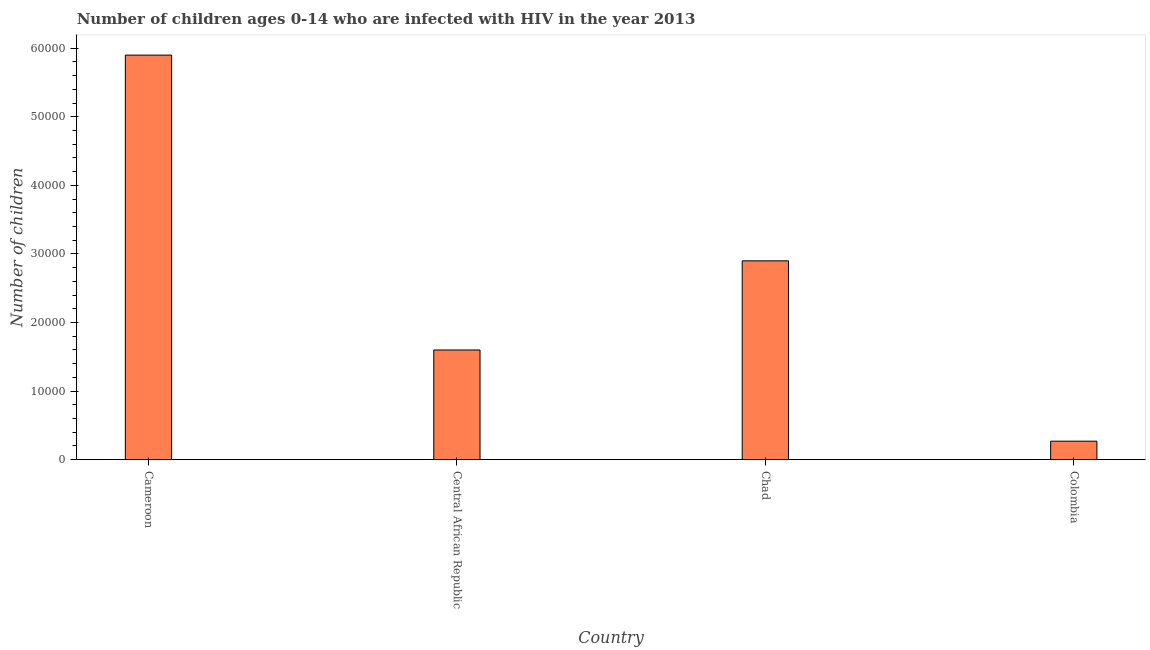Does the graph contain any zero values?
Provide a short and direct response. No. Does the graph contain grids?
Your response must be concise. No. What is the title of the graph?
Offer a very short reply. Number of children ages 0-14 who are infected with HIV in the year 2013. What is the label or title of the Y-axis?
Your answer should be very brief. Number of children. What is the number of children living with hiv in Colombia?
Provide a succinct answer. 2700. Across all countries, what is the maximum number of children living with hiv?
Your response must be concise. 5.90e+04. Across all countries, what is the minimum number of children living with hiv?
Provide a short and direct response. 2700. In which country was the number of children living with hiv maximum?
Provide a short and direct response. Cameroon. What is the sum of the number of children living with hiv?
Make the answer very short. 1.07e+05. What is the difference between the number of children living with hiv in Cameroon and Colombia?
Your answer should be very brief. 5.63e+04. What is the average number of children living with hiv per country?
Give a very brief answer. 2.67e+04. What is the median number of children living with hiv?
Keep it short and to the point. 2.25e+04. What is the ratio of the number of children living with hiv in Cameroon to that in Central African Republic?
Provide a succinct answer. 3.69. Is the number of children living with hiv in Cameroon less than that in Colombia?
Provide a short and direct response. No. Is the difference between the number of children living with hiv in Cameroon and Chad greater than the difference between any two countries?
Make the answer very short. No. What is the difference between the highest and the lowest number of children living with hiv?
Keep it short and to the point. 5.63e+04. Are all the bars in the graph horizontal?
Keep it short and to the point. No. What is the Number of children in Cameroon?
Keep it short and to the point. 5.90e+04. What is the Number of children in Central African Republic?
Your response must be concise. 1.60e+04. What is the Number of children of Chad?
Your answer should be compact. 2.90e+04. What is the Number of children in Colombia?
Give a very brief answer. 2700. What is the difference between the Number of children in Cameroon and Central African Republic?
Give a very brief answer. 4.30e+04. What is the difference between the Number of children in Cameroon and Colombia?
Your answer should be compact. 5.63e+04. What is the difference between the Number of children in Central African Republic and Chad?
Your answer should be compact. -1.30e+04. What is the difference between the Number of children in Central African Republic and Colombia?
Provide a succinct answer. 1.33e+04. What is the difference between the Number of children in Chad and Colombia?
Your response must be concise. 2.63e+04. What is the ratio of the Number of children in Cameroon to that in Central African Republic?
Your answer should be very brief. 3.69. What is the ratio of the Number of children in Cameroon to that in Chad?
Your answer should be compact. 2.03. What is the ratio of the Number of children in Cameroon to that in Colombia?
Make the answer very short. 21.85. What is the ratio of the Number of children in Central African Republic to that in Chad?
Offer a very short reply. 0.55. What is the ratio of the Number of children in Central African Republic to that in Colombia?
Give a very brief answer. 5.93. What is the ratio of the Number of children in Chad to that in Colombia?
Your answer should be very brief. 10.74. 